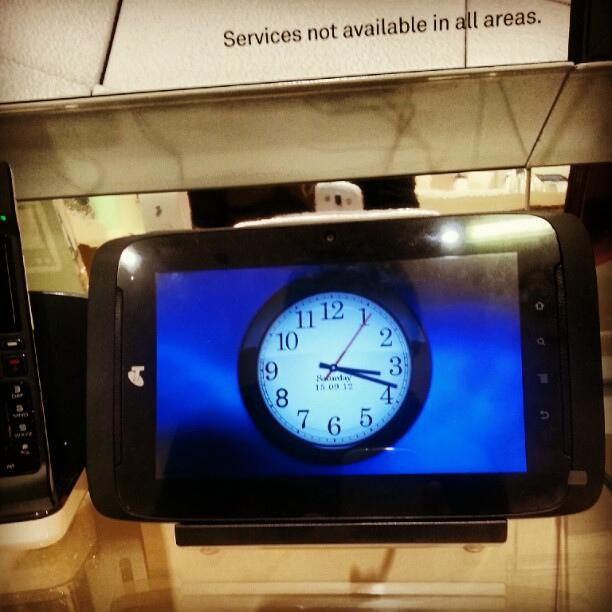What numbered day of the week is it? seven 